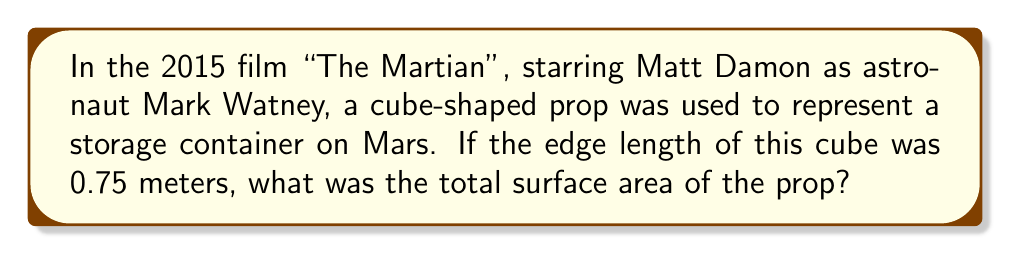Provide a solution to this math problem. Let's approach this step-by-step:

1) The surface area of a cube is given by the formula:
   $$A = 6s^2$$
   where $A$ is the surface area and $s$ is the length of an edge.

2) We are given that the edge length is 0.75 meters.

3) Let's substitute this into our formula:
   $$A = 6 \cdot (0.75 \text{ m})^2$$

4) First, let's calculate the square of 0.75:
   $$(0.75 \text{ m})^2 = 0.5625 \text{ m}^2$$

5) Now, we multiply this by 6:
   $$A = 6 \cdot 0.5625 \text{ m}^2 = 3.375 \text{ m}^2$$

Therefore, the total surface area of the cube-shaped prop is 3.375 square meters.
Answer: $3.375 \text{ m}^2$ 